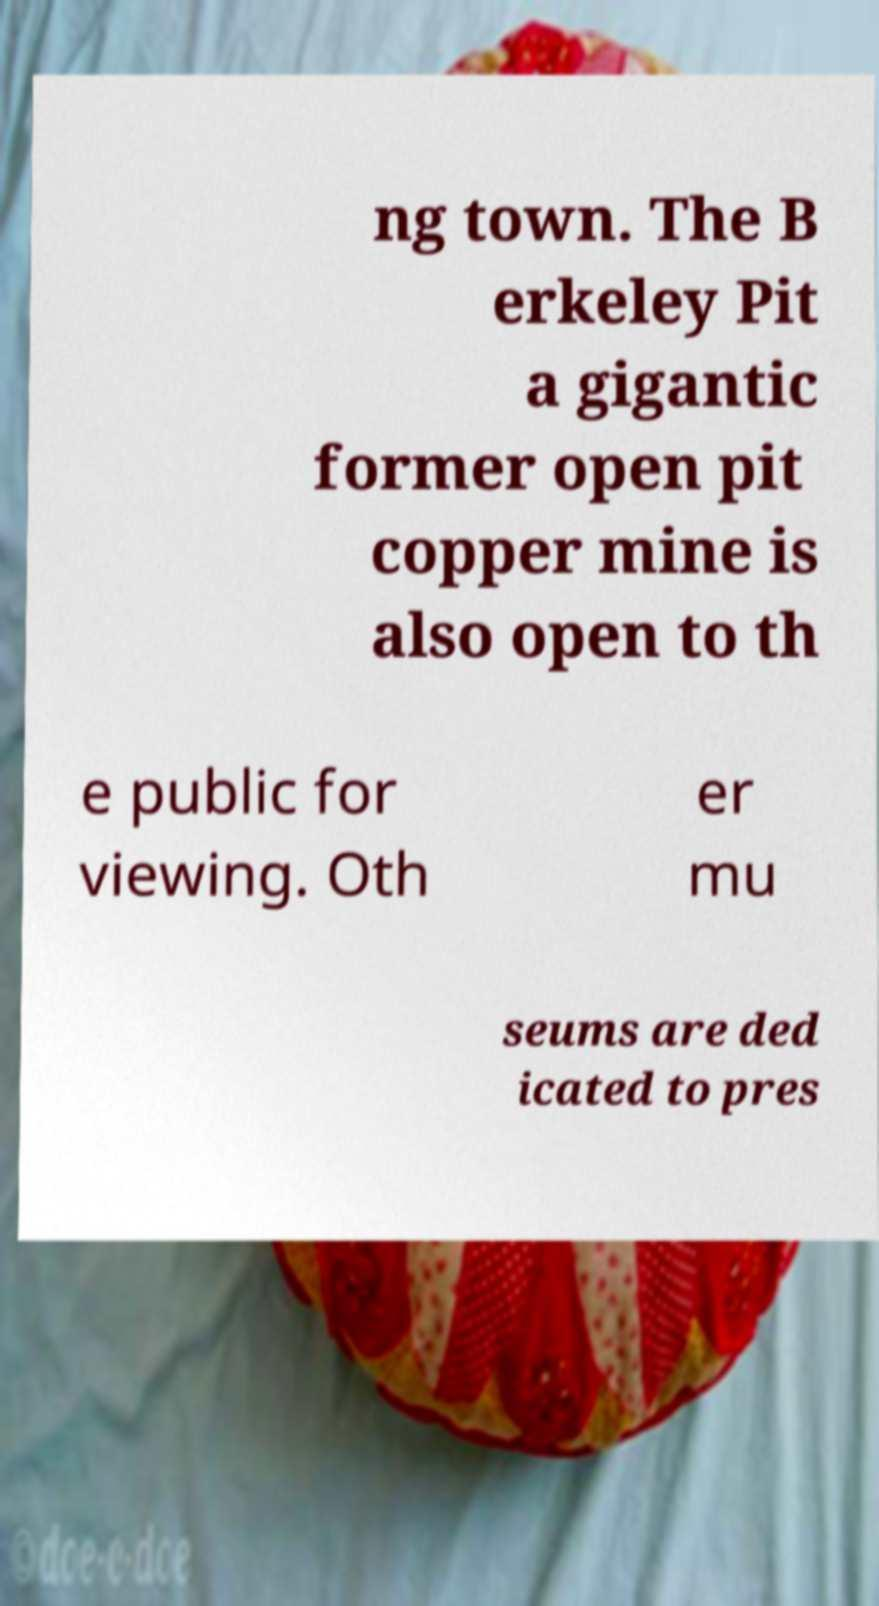What messages or text are displayed in this image? I need them in a readable, typed format. ng town. The B erkeley Pit a gigantic former open pit copper mine is also open to th e public for viewing. Oth er mu seums are ded icated to pres 